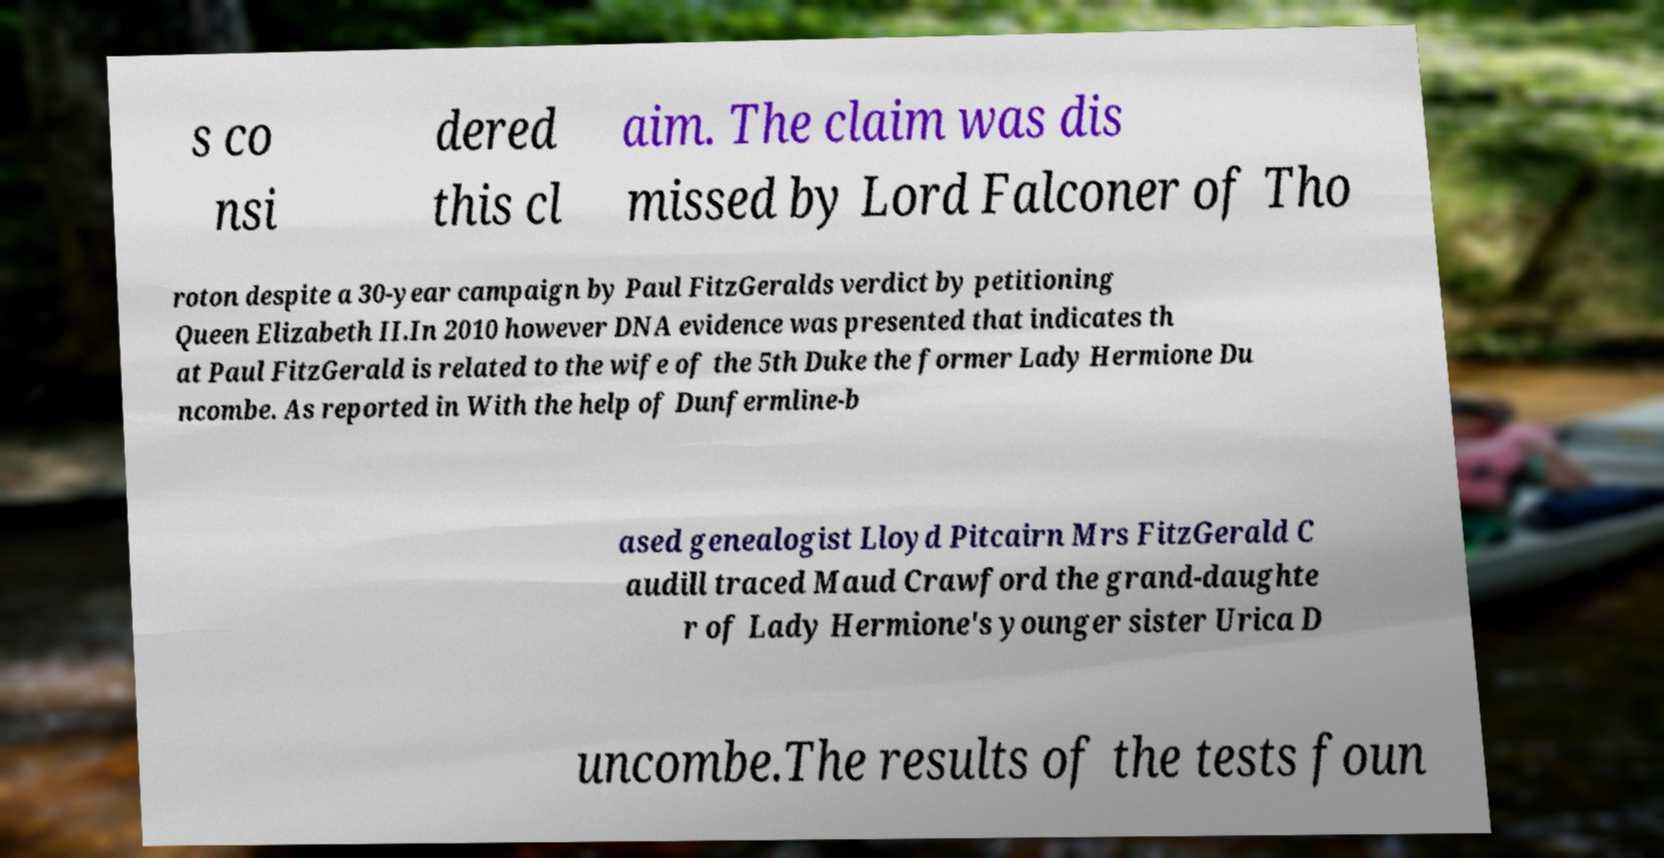Can you read and provide the text displayed in the image?This photo seems to have some interesting text. Can you extract and type it out for me? s co nsi dered this cl aim. The claim was dis missed by Lord Falconer of Tho roton despite a 30-year campaign by Paul FitzGeralds verdict by petitioning Queen Elizabeth II.In 2010 however DNA evidence was presented that indicates th at Paul FitzGerald is related to the wife of the 5th Duke the former Lady Hermione Du ncombe. As reported in With the help of Dunfermline-b ased genealogist Lloyd Pitcairn Mrs FitzGerald C audill traced Maud Crawford the grand-daughte r of Lady Hermione's younger sister Urica D uncombe.The results of the tests foun 